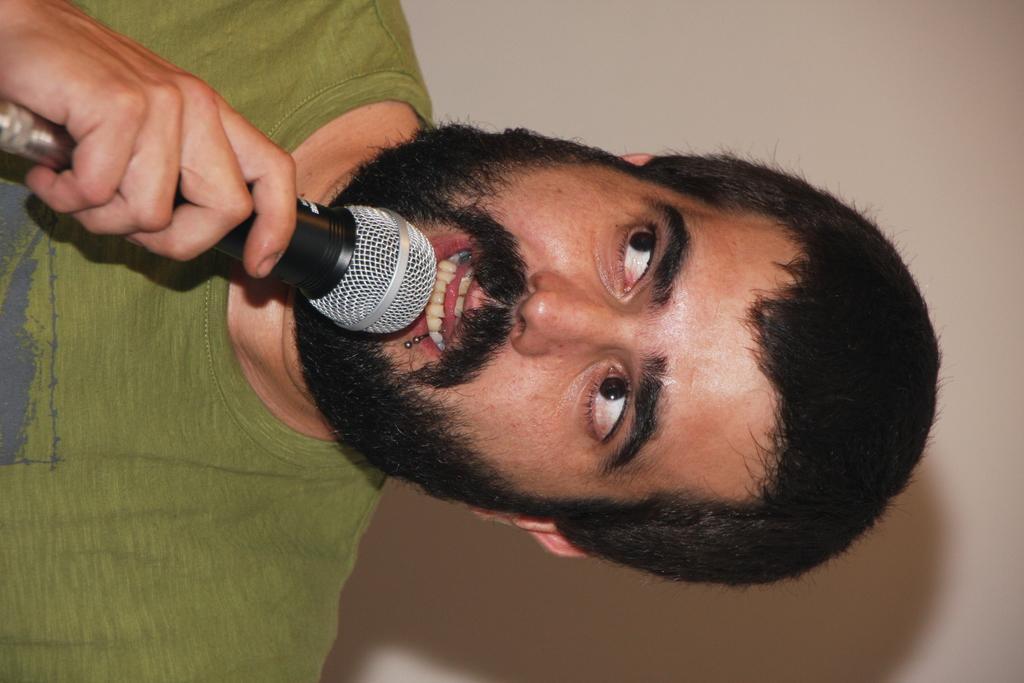In one or two sentences, can you explain what this image depicts? In this image, There is a man standing and holding a microphone which is in black color, He is speaking in the microphone, In the background there is a white color wall. 